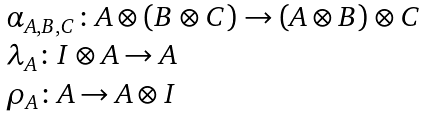<formula> <loc_0><loc_0><loc_500><loc_500>\begin{array} { l } \alpha _ { A , B , C } \colon A \otimes ( B \otimes C ) \rightarrow ( A \otimes B ) \otimes C \\ \lambda _ { A } \colon I \otimes A \rightarrow A \\ \rho _ { A } \colon A \rightarrow A \otimes I \end{array}</formula> 